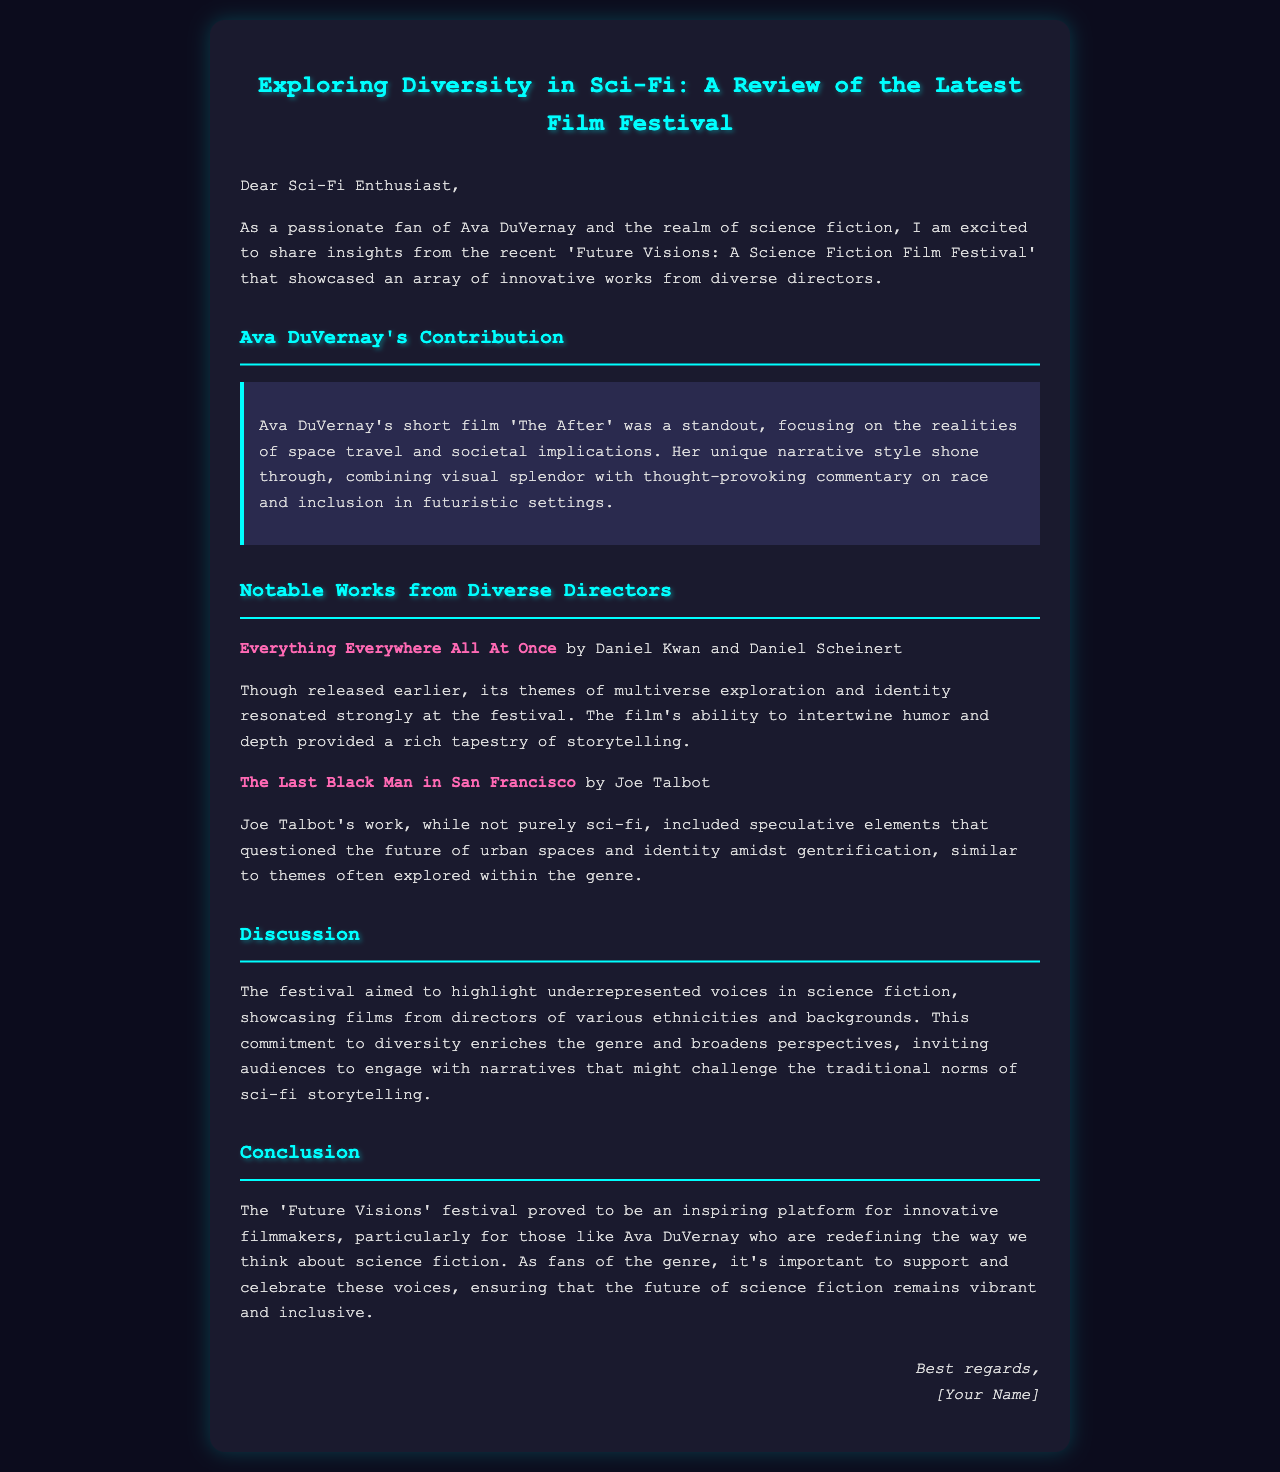What is the title of Ava DuVernay's short film? The document states that Ava DuVernay's short film is titled 'The After'.
Answer: 'The After' What themes are explored in 'The After'? The highlight mentions that 'The After' focuses on the realities of space travel and societal implications, combining visual splendor with thought-provoking commentary on race and inclusion.
Answer: Space travel and societal implications Which film by Daniel Kwan and Daniel Scheinert is mentioned? The document specifies the film 'Everything Everywhere All At Once' by Daniel Kwan and Daniel Scheinert.
Answer: Everything Everywhere All At Once What is the main goal of the festival? The document says the festival aimed to highlight underrepresented voices in science fiction, enriching the genre with diverse perspectives.
Answer: Highlight underrepresented voices Who directed 'The Last Black Man in San Francisco'? The review indicates that 'The Last Black Man in San Francisco' was directed by Joe Talbot.
Answer: Joe Talbot What is the document type? The content is structured as a review and addresses the audience as 'Dear Sci-Fi Enthusiast', indicating it is an email.
Answer: Email How does the festival enrich the genre? The document discusses the commitment to diversity as a means of enriching the genre and broadening perspectives.
Answer: Committed to diversity What does the festival name imply about its content? The name 'Future Visions' suggests that the festival features films focused on futuristic themes and concepts, aligning with the sci-fi genre.
Answer: Futuristic themes 